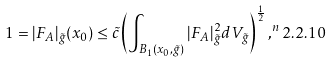Convert formula to latex. <formula><loc_0><loc_0><loc_500><loc_500>1 = | F _ { A } | _ { \tilde { g } } ( x _ { 0 } ) \leq \tilde { c } \left ( \int _ { B _ { 1 } ( x _ { 0 } , \tilde { g } ) } | F _ { A } | ^ { 2 } _ { \tilde { g } } d V _ { \tilde { g } } \right ) ^ { \frac { 1 } { 2 } } , ^ { n } { 2 . 2 . 1 0 }</formula> 